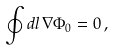Convert formula to latex. <formula><loc_0><loc_0><loc_500><loc_500>\oint d { l } \, \nabla \Phi _ { 0 } = 0 \, ,</formula> 